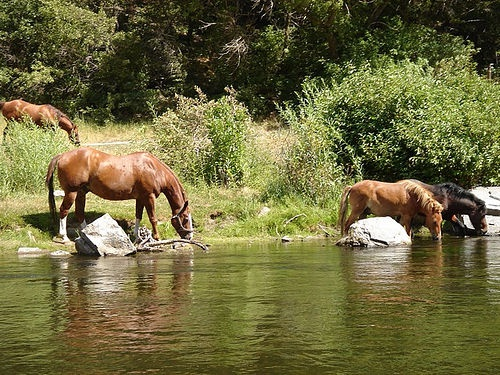Describe the objects in this image and their specific colors. I can see horse in darkgreen, black, maroon, and tan tones, horse in darkgreen, maroon, black, and tan tones, horse in darkgreen, tan, and maroon tones, and horse in darkgreen, black, gray, and white tones in this image. 